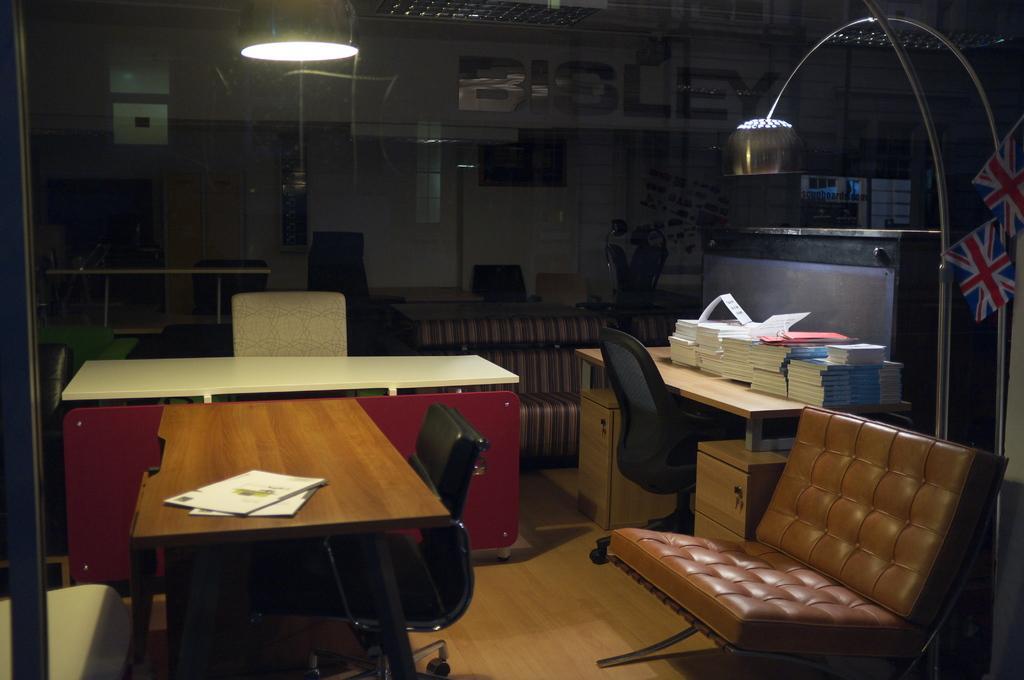Please provide a concise description of this image. there is a table on which papers are kept. there is a black chair in front of it. behind that there is another white table and chair. at the right there is a another table and chair. on the table there are many books. there is a lamp above it. in front of it there is a brown sofa. above that there are flags. 